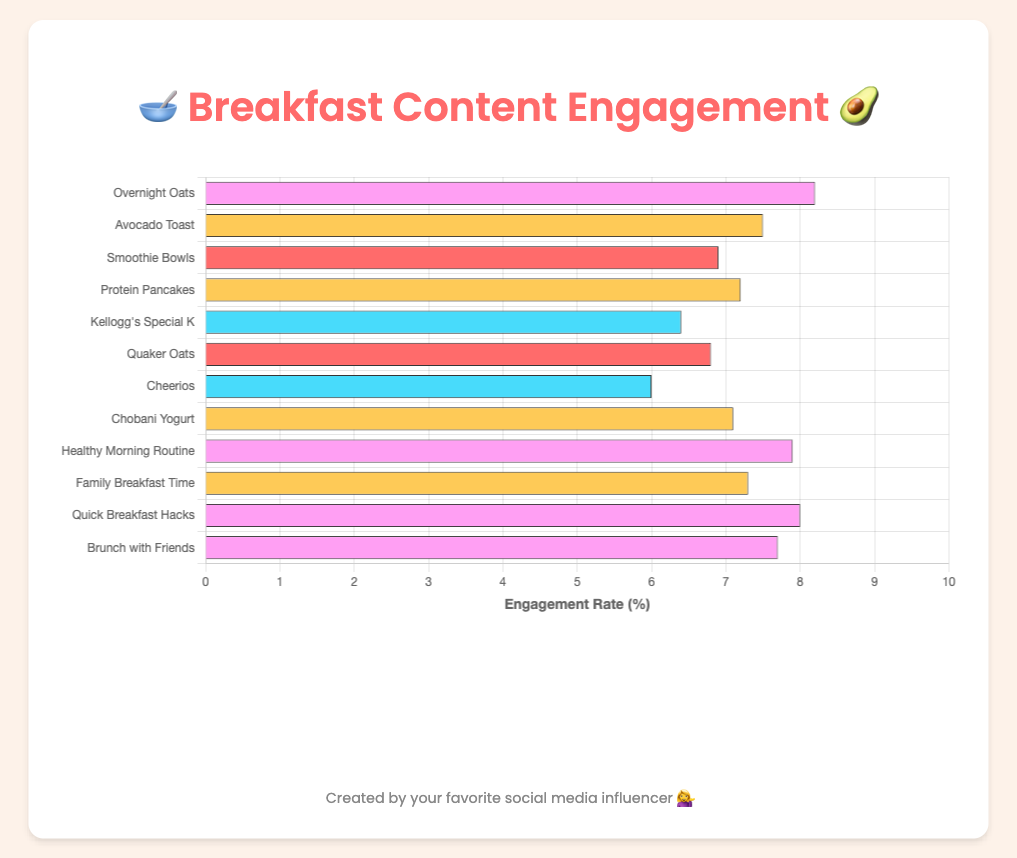Which type of content has the highest engagement rate? Look at the bar chart and find the longest bar, which represents the highest engagement rate. The entity with the longest bar is "Overnight Oats" under the "recipes" category with an engagement rate of 8.2%.
Answer: recipes (Overnight Oats) What is the average engagement rate for product review posts? Calculate the average by summing the engagement rates of all product review posts and then dividing by the number of them: (6.4 + 6.8 + 6.0 + 7.1) / 4 = 26.3 / 4.
Answer: 6.575 Which recipe has the lowest engagement rate? Refer to the bars under the "recipes" category and find the shortest one, which is "Smoothie Bowls" with an engagement rate of 6.9%.
Answer: Smoothie Bowls How does the engagement rate of "Healthy Morning Routine" compare to "Quick Breakfast Hacks"? Compare the lengths of the bars for "Healthy Morning Routine" and "Quick Breakfast Hacks". "Healthy Morning Routine" has an engagement rate of 7.9%, while "Quick Breakfast Hacks" has an engagement rate of 8.0%.
Answer: "Quick Breakfast Hacks" has a slightly higher engagement rate What is the total engagement rate for all lifestyle posts combined? Add the engagement rates of all lifestyle posts: 7.9 + 7.3 + 8.0 + 7.7.
Answer: 30.9 If we combine all the entries, what is the highest possible engagement rate we can have in a single category? The single highest engagement rate across all categories is "Overnight Oats" in the recipes category with an engagement rate of 8.2%.
Answer: 8.2% Which type of post (recipes, product reviews, lifestyle posts) appears most frequently in the chart? Count the number of entries under each type. Recipes and lifestyle posts both have 4 entries, while product reviews also have 4 entries.
Answer: All types are equally frequent What is the difference in engagement rate between "Avocado Toast" and "Protein Pancakes"? Subtract the engagement rate of "Protein Pancakes" (7.2%) from "Avocado Toast" (7.5%).
Answer: 0.3 What is the engagement rate of the most engaging lifestyle post? Check the engagement rates of all lifestyle posts and identify the highest value, which is "Quick Breakfast Hacks" at 8.0%.
Answer: 8.0% Between "Chobani Yogurt" and "Cheerios", which has a higher engagement rate and by how much? Compare the engagement rates of "Chobani Yogurt" (7.1%) and "Cheerios" (6.0%). Subtract to find the difference: 7.1 - 6.0.
Answer: Chobani Yogurt by 1.1% 